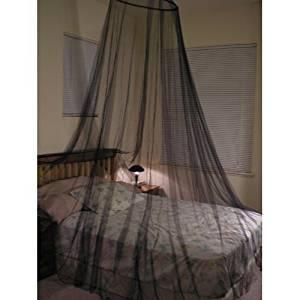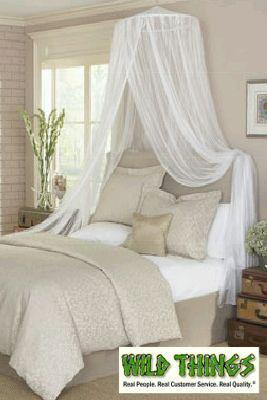The first image is the image on the left, the second image is the image on the right. For the images shown, is this caption "There is at least one child in each bed." true? Answer yes or no. No. The first image is the image on the left, the second image is the image on the right. Considering the images on both sides, is "There are two canopies with at least two child." valid? Answer yes or no. No. 